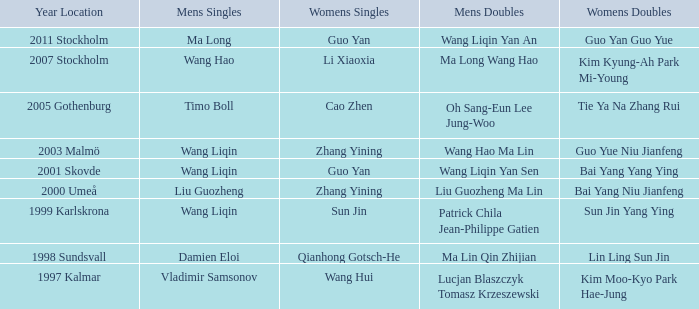How many times has Ma Long won the men's singles? 1.0. 